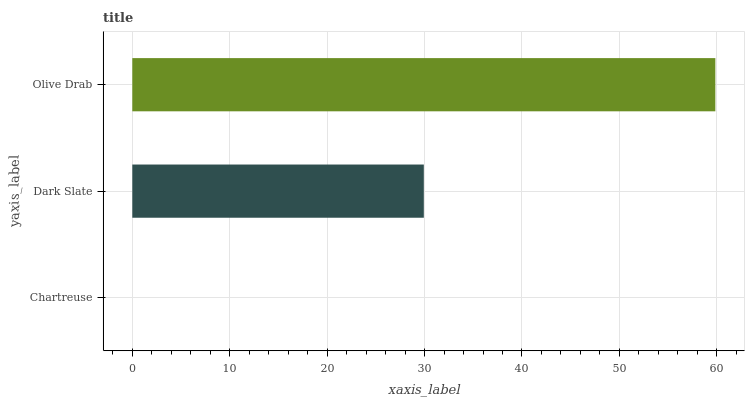Is Chartreuse the minimum?
Answer yes or no. Yes. Is Olive Drab the maximum?
Answer yes or no. Yes. Is Dark Slate the minimum?
Answer yes or no. No. Is Dark Slate the maximum?
Answer yes or no. No. Is Dark Slate greater than Chartreuse?
Answer yes or no. Yes. Is Chartreuse less than Dark Slate?
Answer yes or no. Yes. Is Chartreuse greater than Dark Slate?
Answer yes or no. No. Is Dark Slate less than Chartreuse?
Answer yes or no. No. Is Dark Slate the high median?
Answer yes or no. Yes. Is Dark Slate the low median?
Answer yes or no. Yes. Is Chartreuse the high median?
Answer yes or no. No. Is Chartreuse the low median?
Answer yes or no. No. 